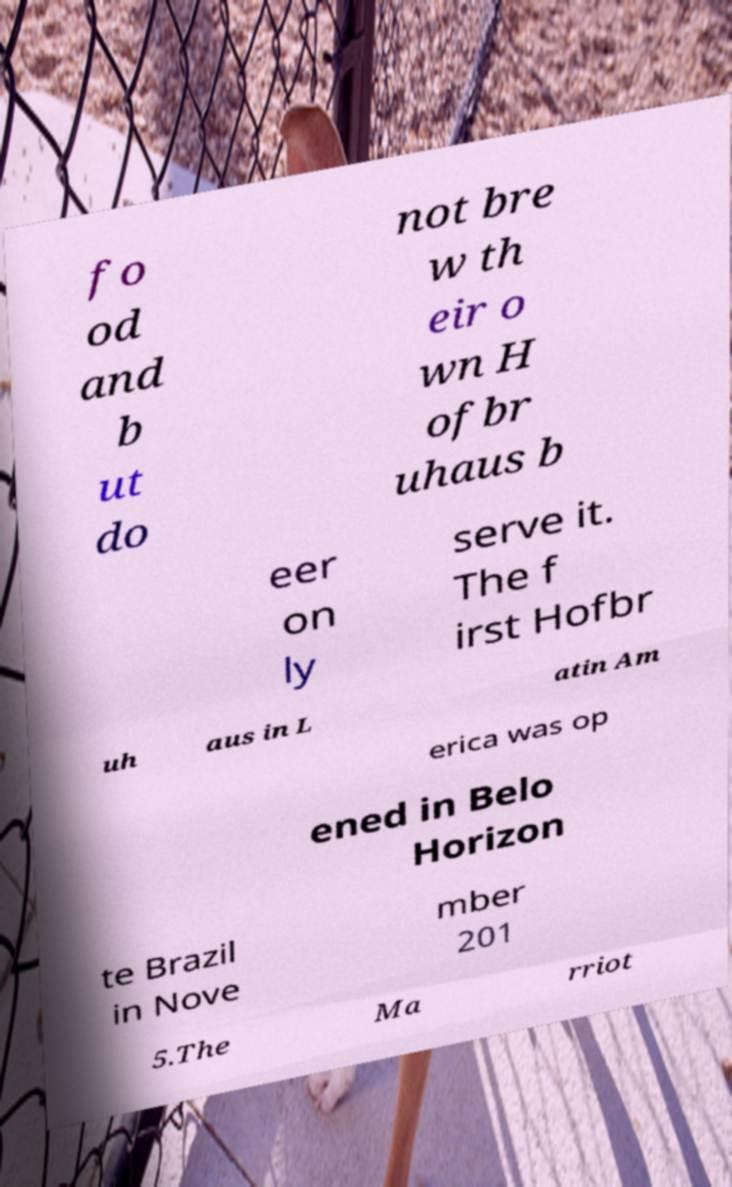For documentation purposes, I need the text within this image transcribed. Could you provide that? fo od and b ut do not bre w th eir o wn H ofbr uhaus b eer on ly serve it. The f irst Hofbr uh aus in L atin Am erica was op ened in Belo Horizon te Brazil in Nove mber 201 5.The Ma rriot 